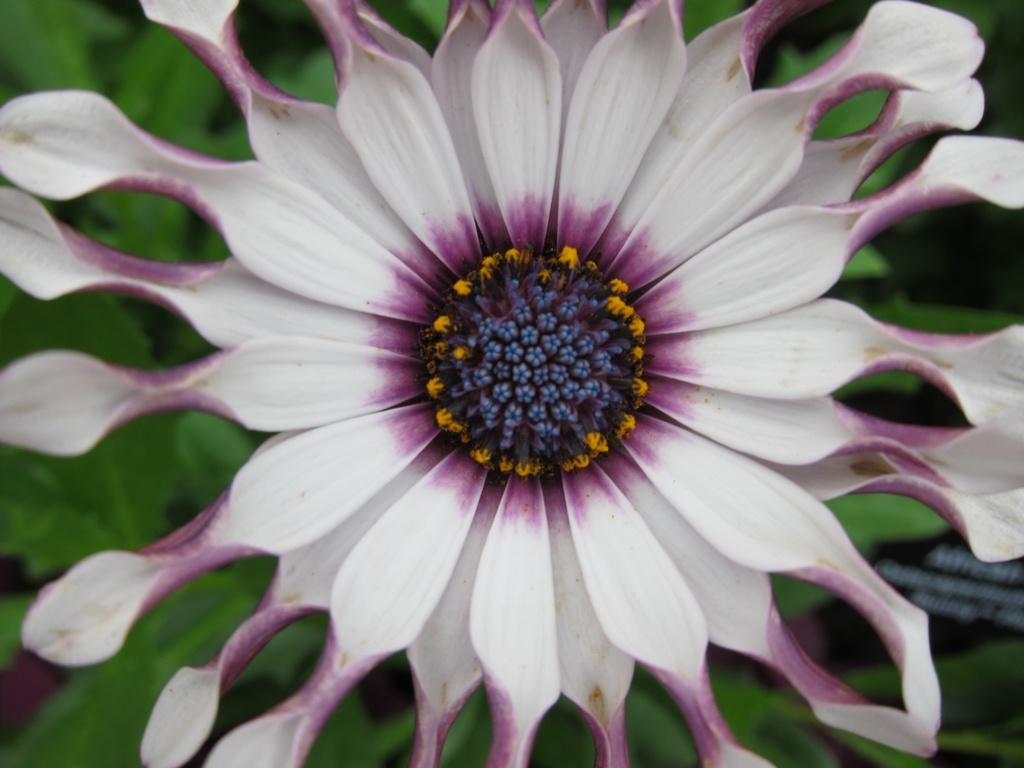What is the main subject of the image? There is a flower in the center of the image. What can be seen in the background of the image? There are leaves in the background of the image. What type of cake is being pushed by the pet in the image? There is no cake or pet present in the image; it features a flower and leaves. 